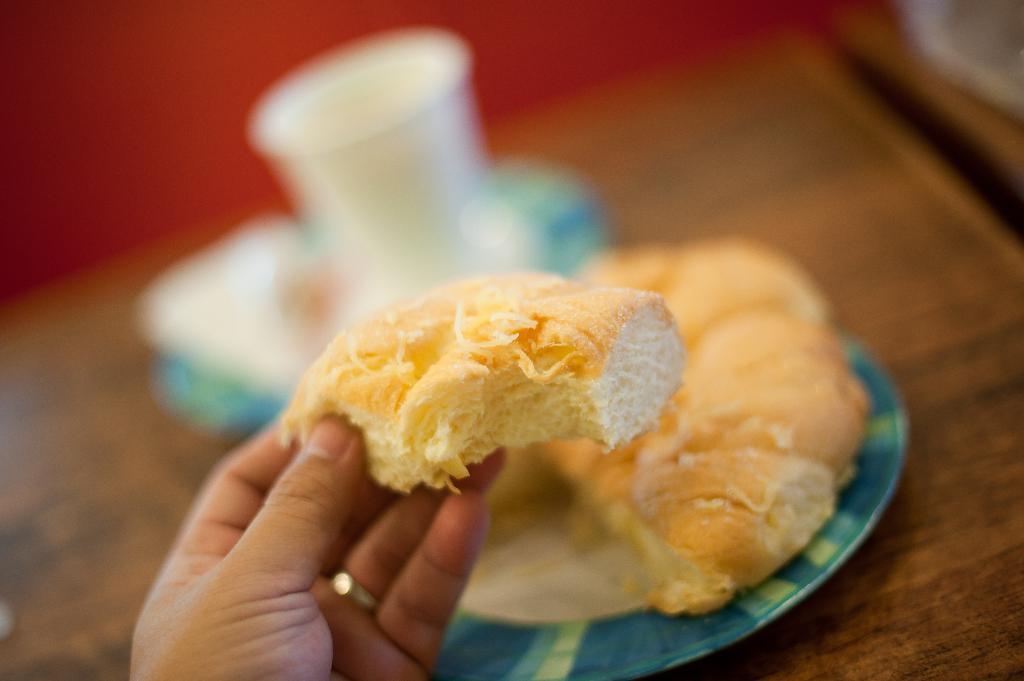In one or two sentences, can you explain what this image depicts? In this image in front we can see the hand of a person holding the bun. In front of the person there are buns, the cup on the plates which was placed on the table. In the background of the image there is a wall. 